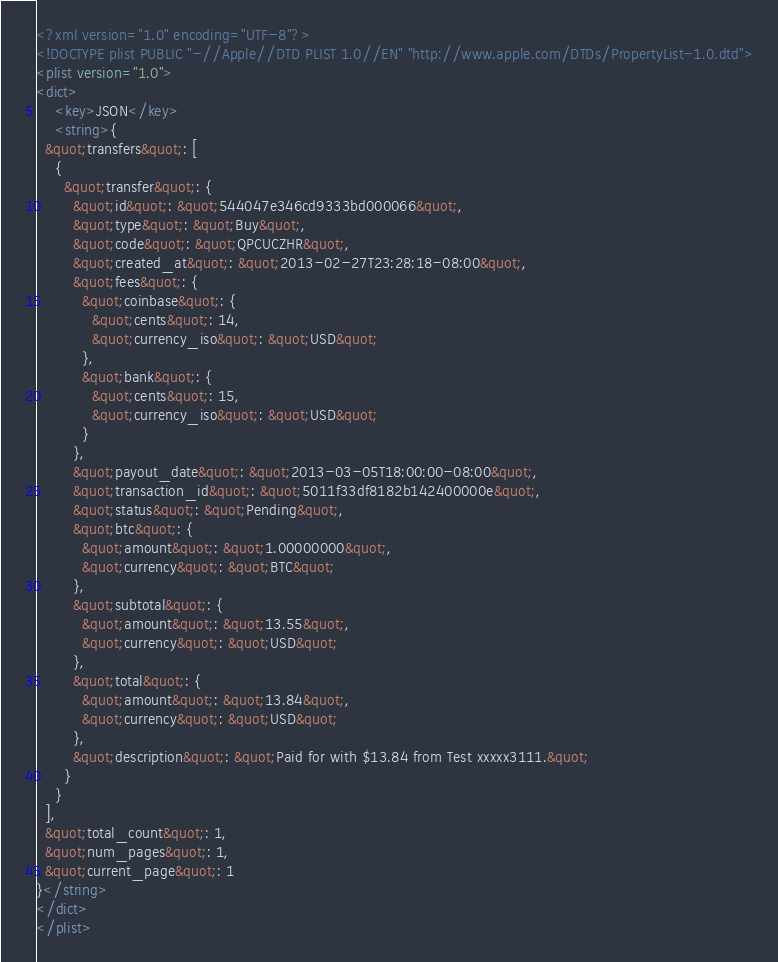Convert code to text. <code><loc_0><loc_0><loc_500><loc_500><_XML_><?xml version="1.0" encoding="UTF-8"?>
<!DOCTYPE plist PUBLIC "-//Apple//DTD PLIST 1.0//EN" "http://www.apple.com/DTDs/PropertyList-1.0.dtd">
<plist version="1.0">
<dict>
	<key>JSON</key>
	<string>{
  &quot;transfers&quot;: [
    {
      &quot;transfer&quot;: {
        &quot;id&quot;: &quot;544047e346cd9333bd000066&quot;,
        &quot;type&quot;: &quot;Buy&quot;,
        &quot;code&quot;: &quot;QPCUCZHR&quot;,
        &quot;created_at&quot;: &quot;2013-02-27T23:28:18-08:00&quot;,
        &quot;fees&quot;: {
          &quot;coinbase&quot;: {
            &quot;cents&quot;: 14,
            &quot;currency_iso&quot;: &quot;USD&quot;
          },
          &quot;bank&quot;: {
            &quot;cents&quot;: 15,
            &quot;currency_iso&quot;: &quot;USD&quot;
          }
        },
        &quot;payout_date&quot;: &quot;2013-03-05T18:00:00-08:00&quot;,
        &quot;transaction_id&quot;: &quot;5011f33df8182b142400000e&quot;,
        &quot;status&quot;: &quot;Pending&quot;,
        &quot;btc&quot;: {
          &quot;amount&quot;: &quot;1.00000000&quot;,
          &quot;currency&quot;: &quot;BTC&quot;
        },
        &quot;subtotal&quot;: {
          &quot;amount&quot;: &quot;13.55&quot;,
          &quot;currency&quot;: &quot;USD&quot;
        },
        &quot;total&quot;: {
          &quot;amount&quot;: &quot;13.84&quot;,
          &quot;currency&quot;: &quot;USD&quot;
        },
        &quot;description&quot;: &quot;Paid for with $13.84 from Test xxxxx3111.&quot;
      }
    }
  ],
  &quot;total_count&quot;: 1,
  &quot;num_pages&quot;: 1,
  &quot;current_page&quot;: 1
}</string>
</dict>
</plist>
</code> 